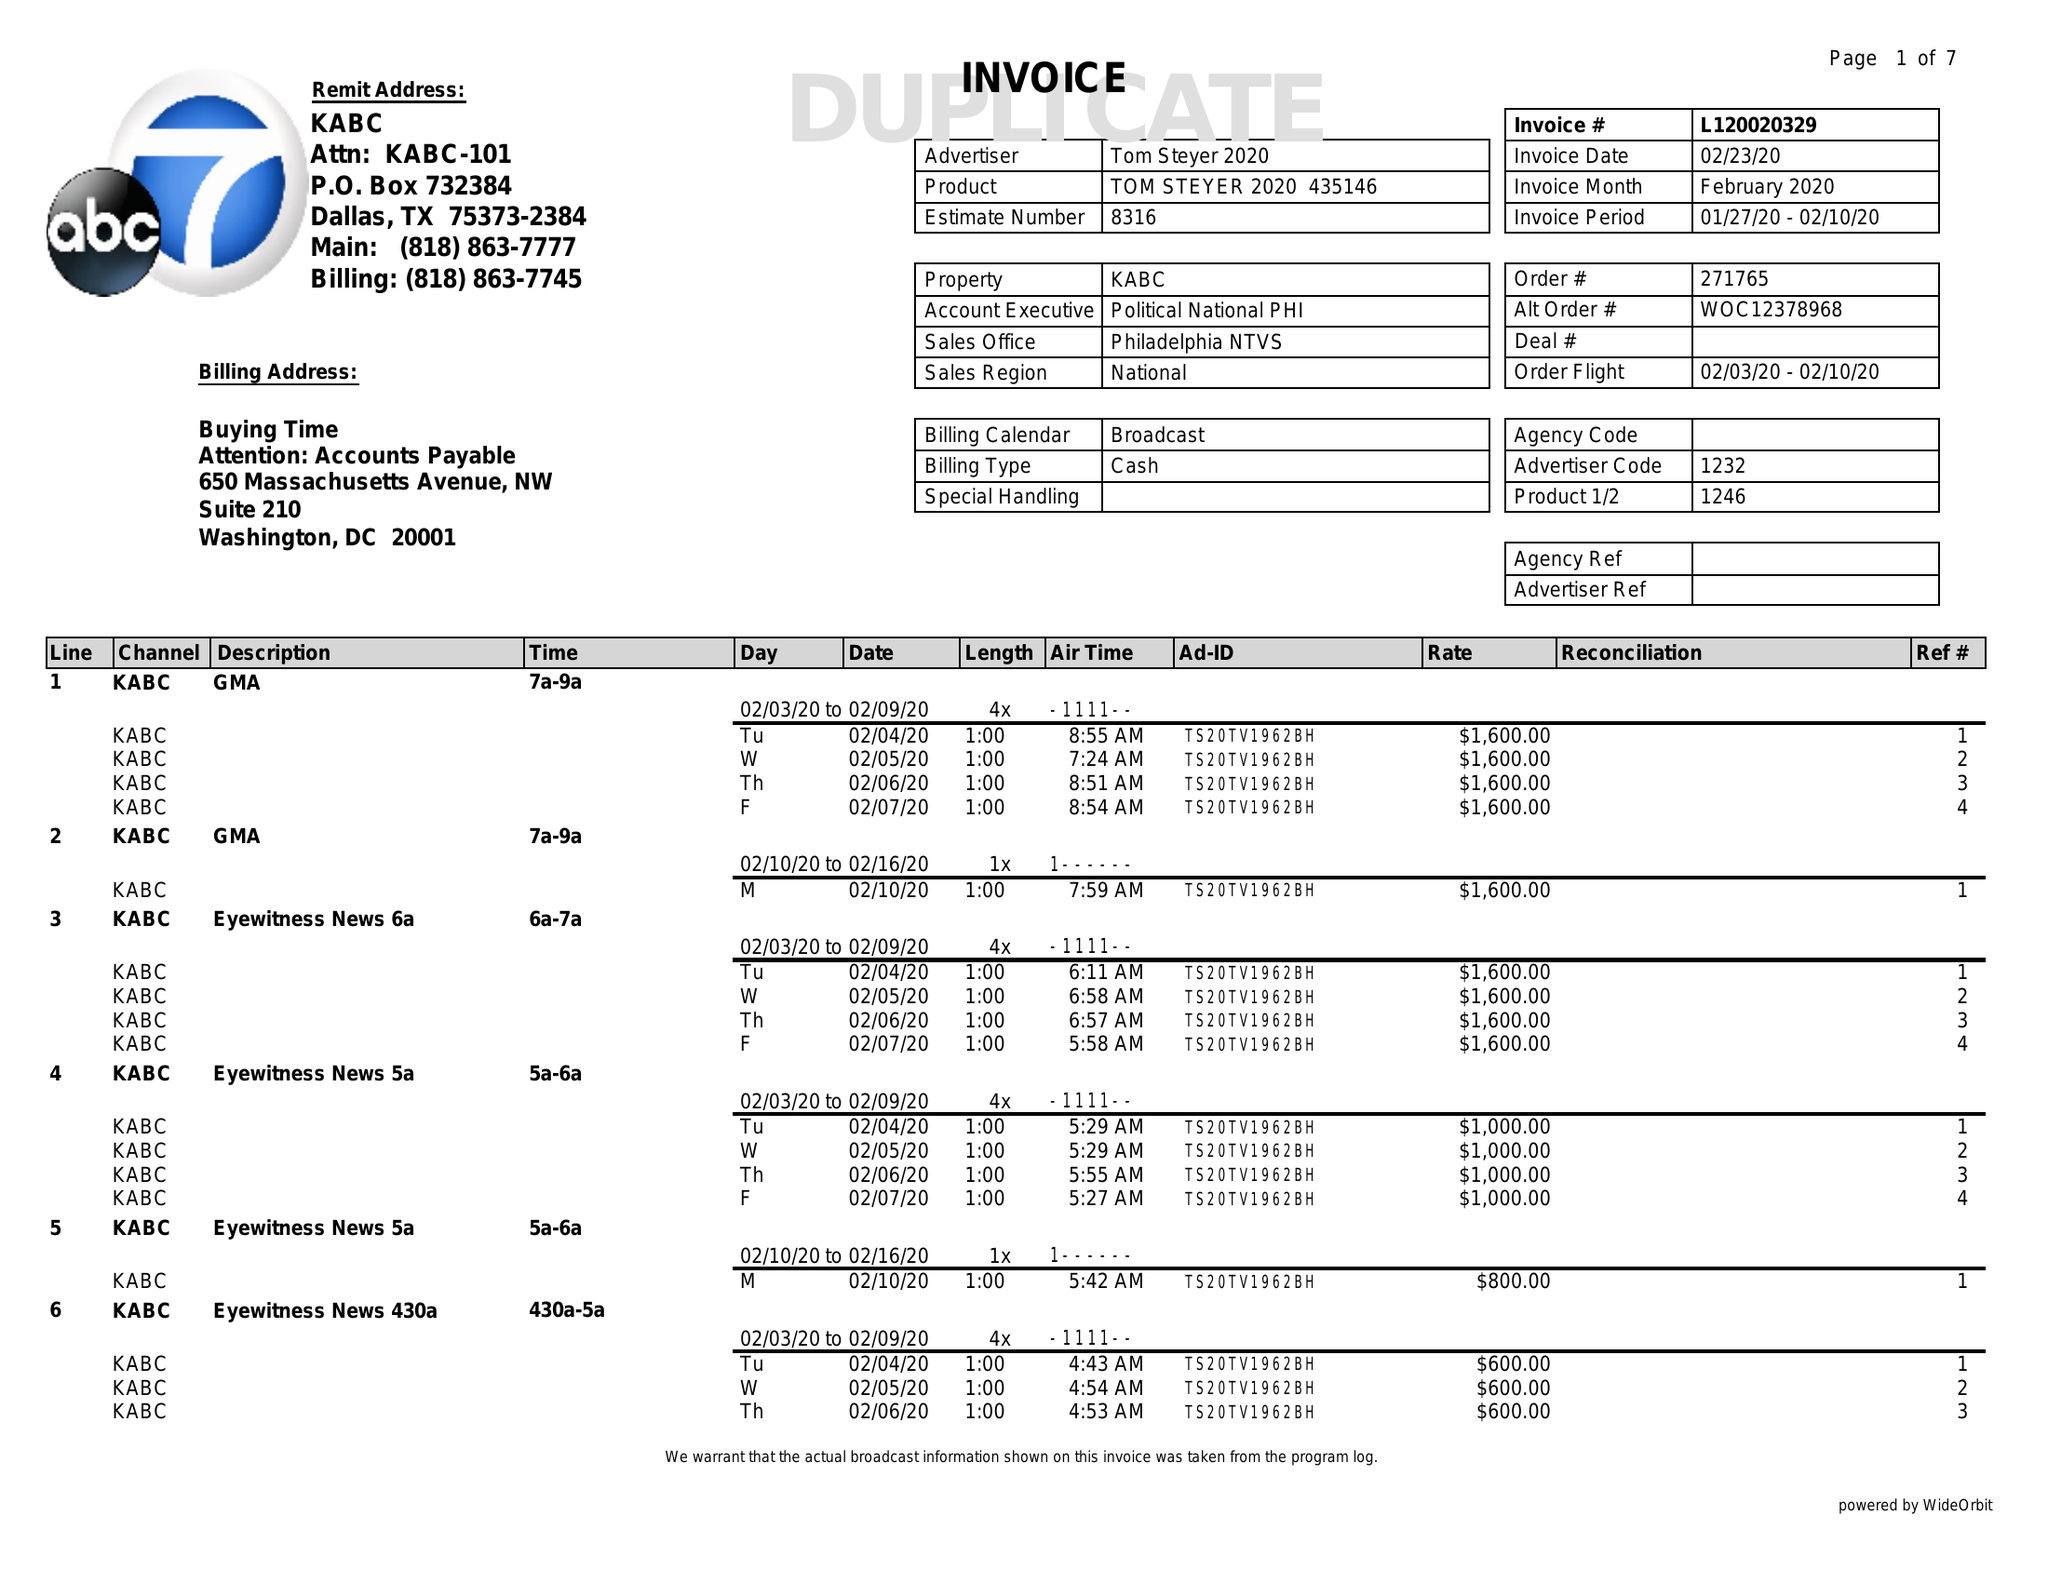What is the value for the flight_from?
Answer the question using a single word or phrase. 02/03/20 